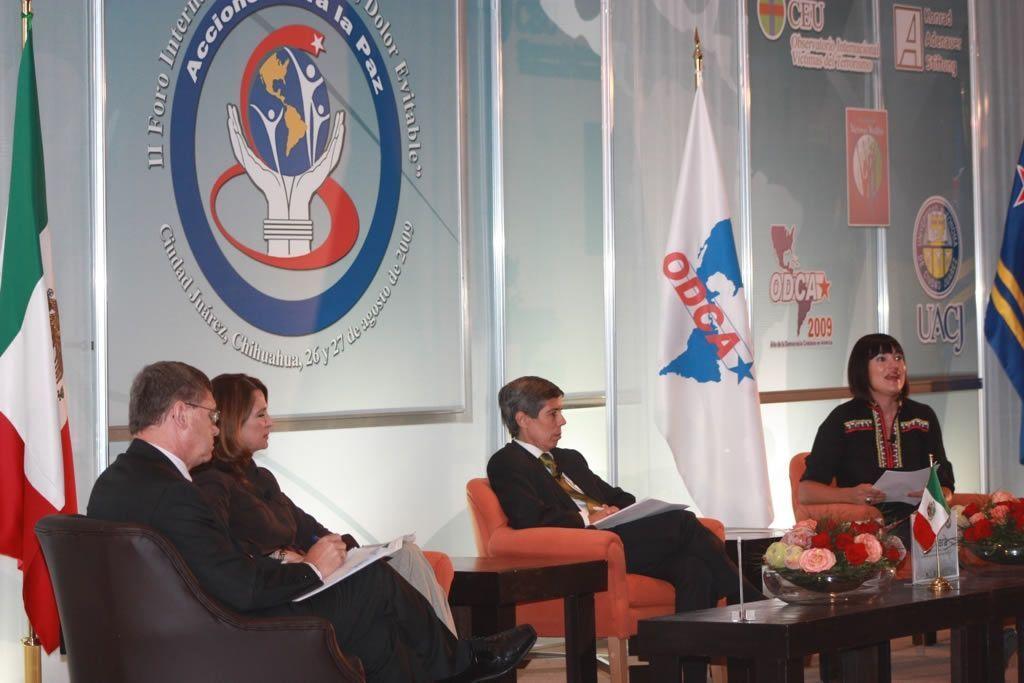Can you describe this image briefly? In this picture we can see four persons sitting on chairs and in front of them we have table and on table we can see flag, bowl with full of flowers and in background we can see logo and in right side we can see some more logo and here are two flags with poles. 